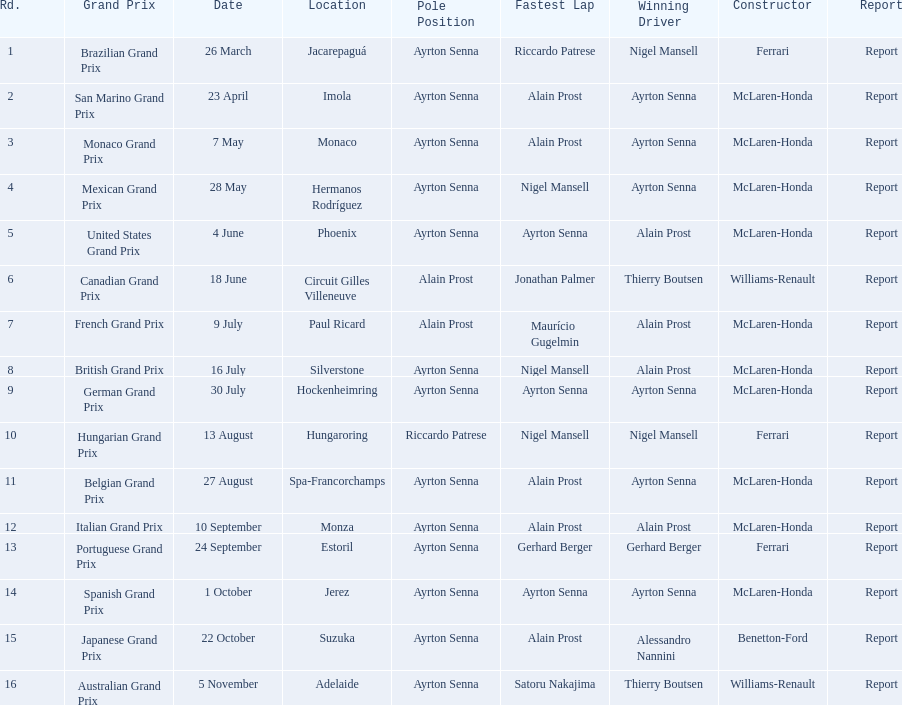How many times did alain prost achieve the fastest lap? 5. 